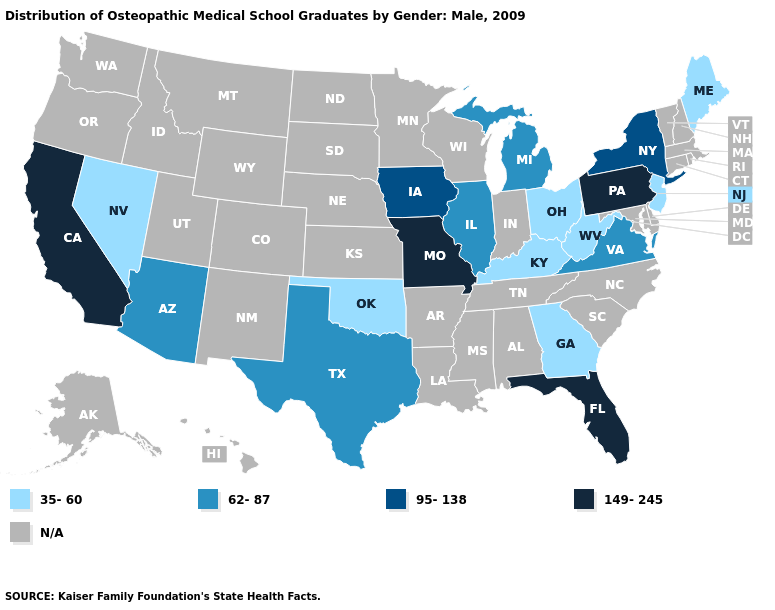Does the map have missing data?
Quick response, please. Yes. What is the value of Georgia?
Quick response, please. 35-60. Name the states that have a value in the range 62-87?
Concise answer only. Arizona, Illinois, Michigan, Texas, Virginia. Among the states that border California , which have the lowest value?
Quick response, please. Nevada. Does Virginia have the lowest value in the USA?
Concise answer only. No. Does the map have missing data?
Give a very brief answer. Yes. Does New Jersey have the highest value in the Northeast?
Be succinct. No. Which states have the lowest value in the West?
Answer briefly. Nevada. Does the map have missing data?
Write a very short answer. Yes. Name the states that have a value in the range 95-138?
Short answer required. Iowa, New York. Does the first symbol in the legend represent the smallest category?
Quick response, please. Yes. What is the value of Oklahoma?
Answer briefly. 35-60. Name the states that have a value in the range 149-245?
Quick response, please. California, Florida, Missouri, Pennsylvania. What is the value of Colorado?
Be succinct. N/A. Which states have the lowest value in the USA?
Be succinct. Georgia, Kentucky, Maine, Nevada, New Jersey, Ohio, Oklahoma, West Virginia. 